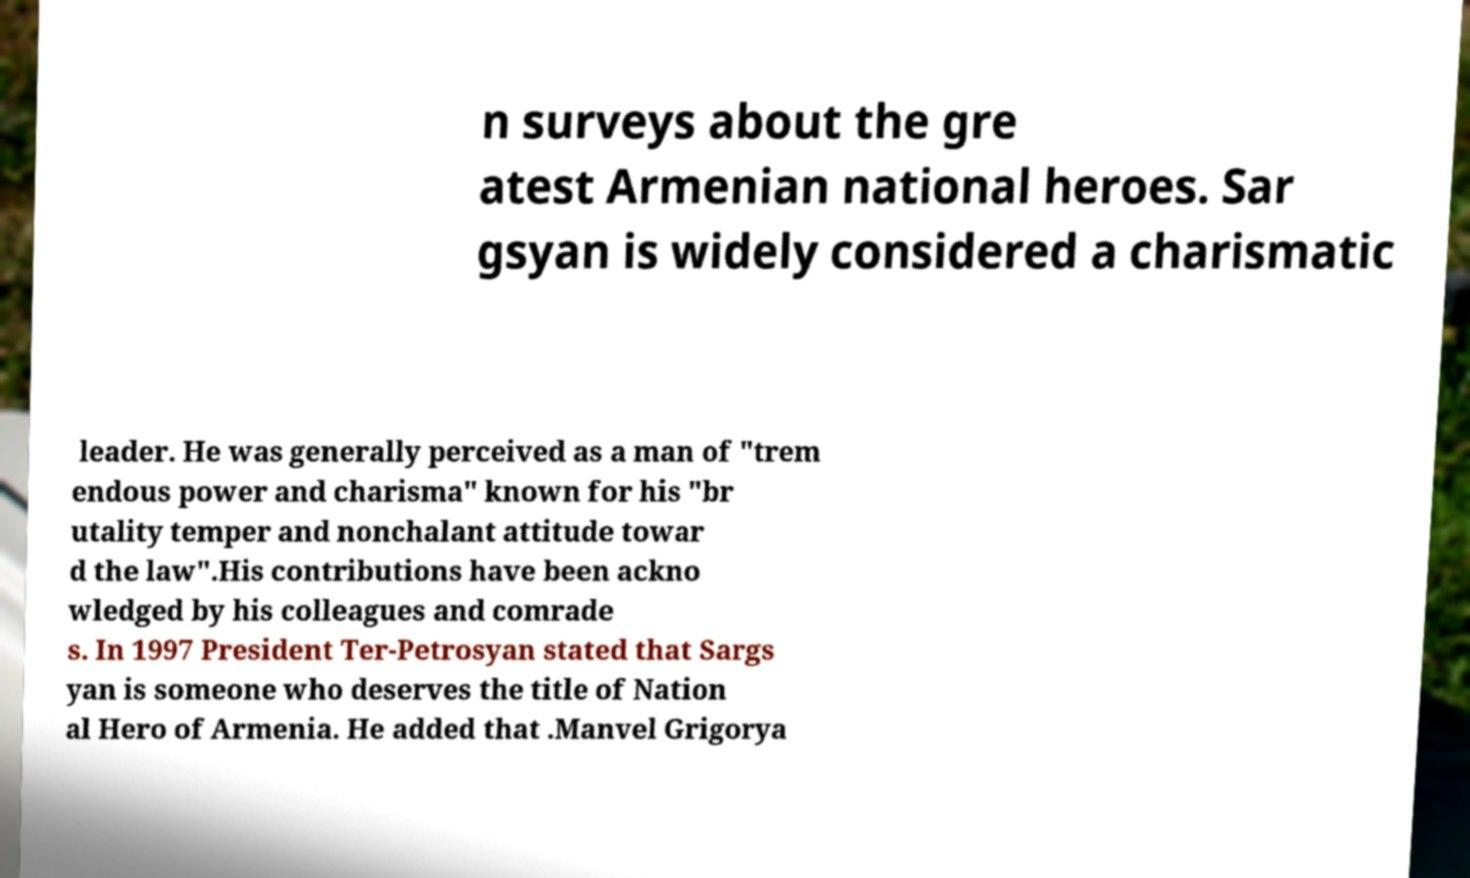Can you accurately transcribe the text from the provided image for me? n surveys about the gre atest Armenian national heroes. Sar gsyan is widely considered a charismatic leader. He was generally perceived as a man of "trem endous power and charisma" known for his "br utality temper and nonchalant attitude towar d the law".His contributions have been ackno wledged by his colleagues and comrade s. In 1997 President Ter-Petrosyan stated that Sargs yan is someone who deserves the title of Nation al Hero of Armenia. He added that .Manvel Grigorya 